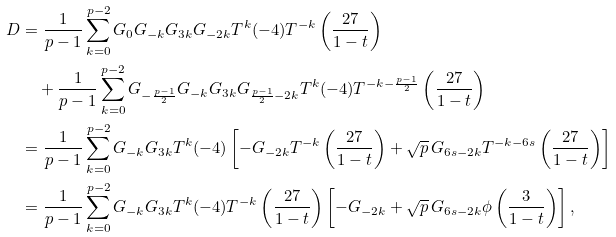Convert formula to latex. <formula><loc_0><loc_0><loc_500><loc_500>D & = \frac { 1 } { p - 1 } \sum _ { k = 0 } ^ { p - 2 } G _ { 0 } G _ { - k } G _ { 3 k } G _ { - 2 k } T ^ { k } ( - 4 ) T ^ { - k } \left ( \frac { 2 7 } { 1 - t } \right ) \\ & \quad + \frac { 1 } { p - 1 } \sum _ { k = 0 } ^ { p - 2 } G _ { - \frac { p - 1 } { 2 } } G _ { - k } G _ { 3 k } G _ { \frac { p - 1 } { 2 } - 2 k } T ^ { k } ( - 4 ) T ^ { - k - \frac { p - 1 } { 2 } } \left ( \frac { 2 7 } { 1 - t } \right ) \\ & = \frac { 1 } { p - 1 } \sum _ { k = 0 } ^ { p - 2 } G _ { - k } G _ { 3 k } T ^ { k } ( - 4 ) \left [ - G _ { - 2 k } T ^ { - k } \left ( \frac { 2 7 } { 1 - t } \right ) + \sqrt { p } \, G _ { 6 s - 2 k } T ^ { - k - 6 s } \left ( \frac { 2 7 } { 1 - t } \right ) \right ] \\ & = \frac { 1 } { p - 1 } \sum _ { k = 0 } ^ { p - 2 } G _ { - k } G _ { 3 k } T ^ { k } ( - 4 ) T ^ { - k } \left ( \frac { 2 7 } { 1 - t } \right ) \left [ - G _ { - 2 k } + \sqrt { p } \, G _ { 6 s - 2 k } \phi \left ( \frac { 3 } { 1 - t } \right ) \right ] ,</formula> 